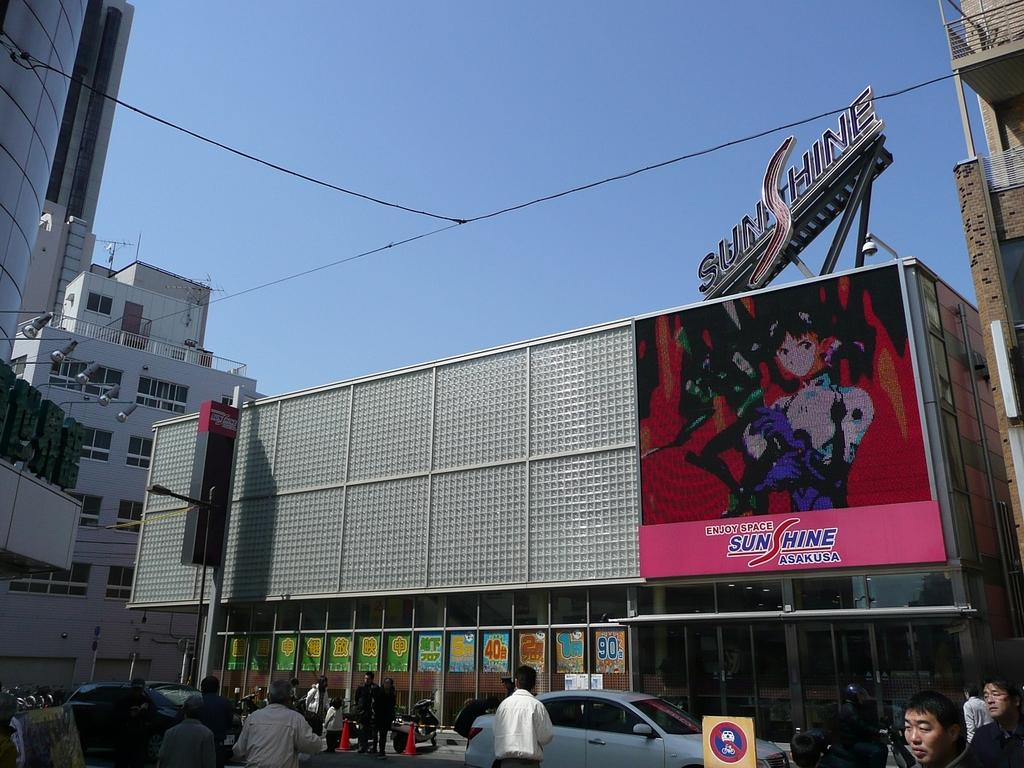Provide a one-sentence caption for the provided image. The ad on the side of the building is for Sunshine Asakusa. 